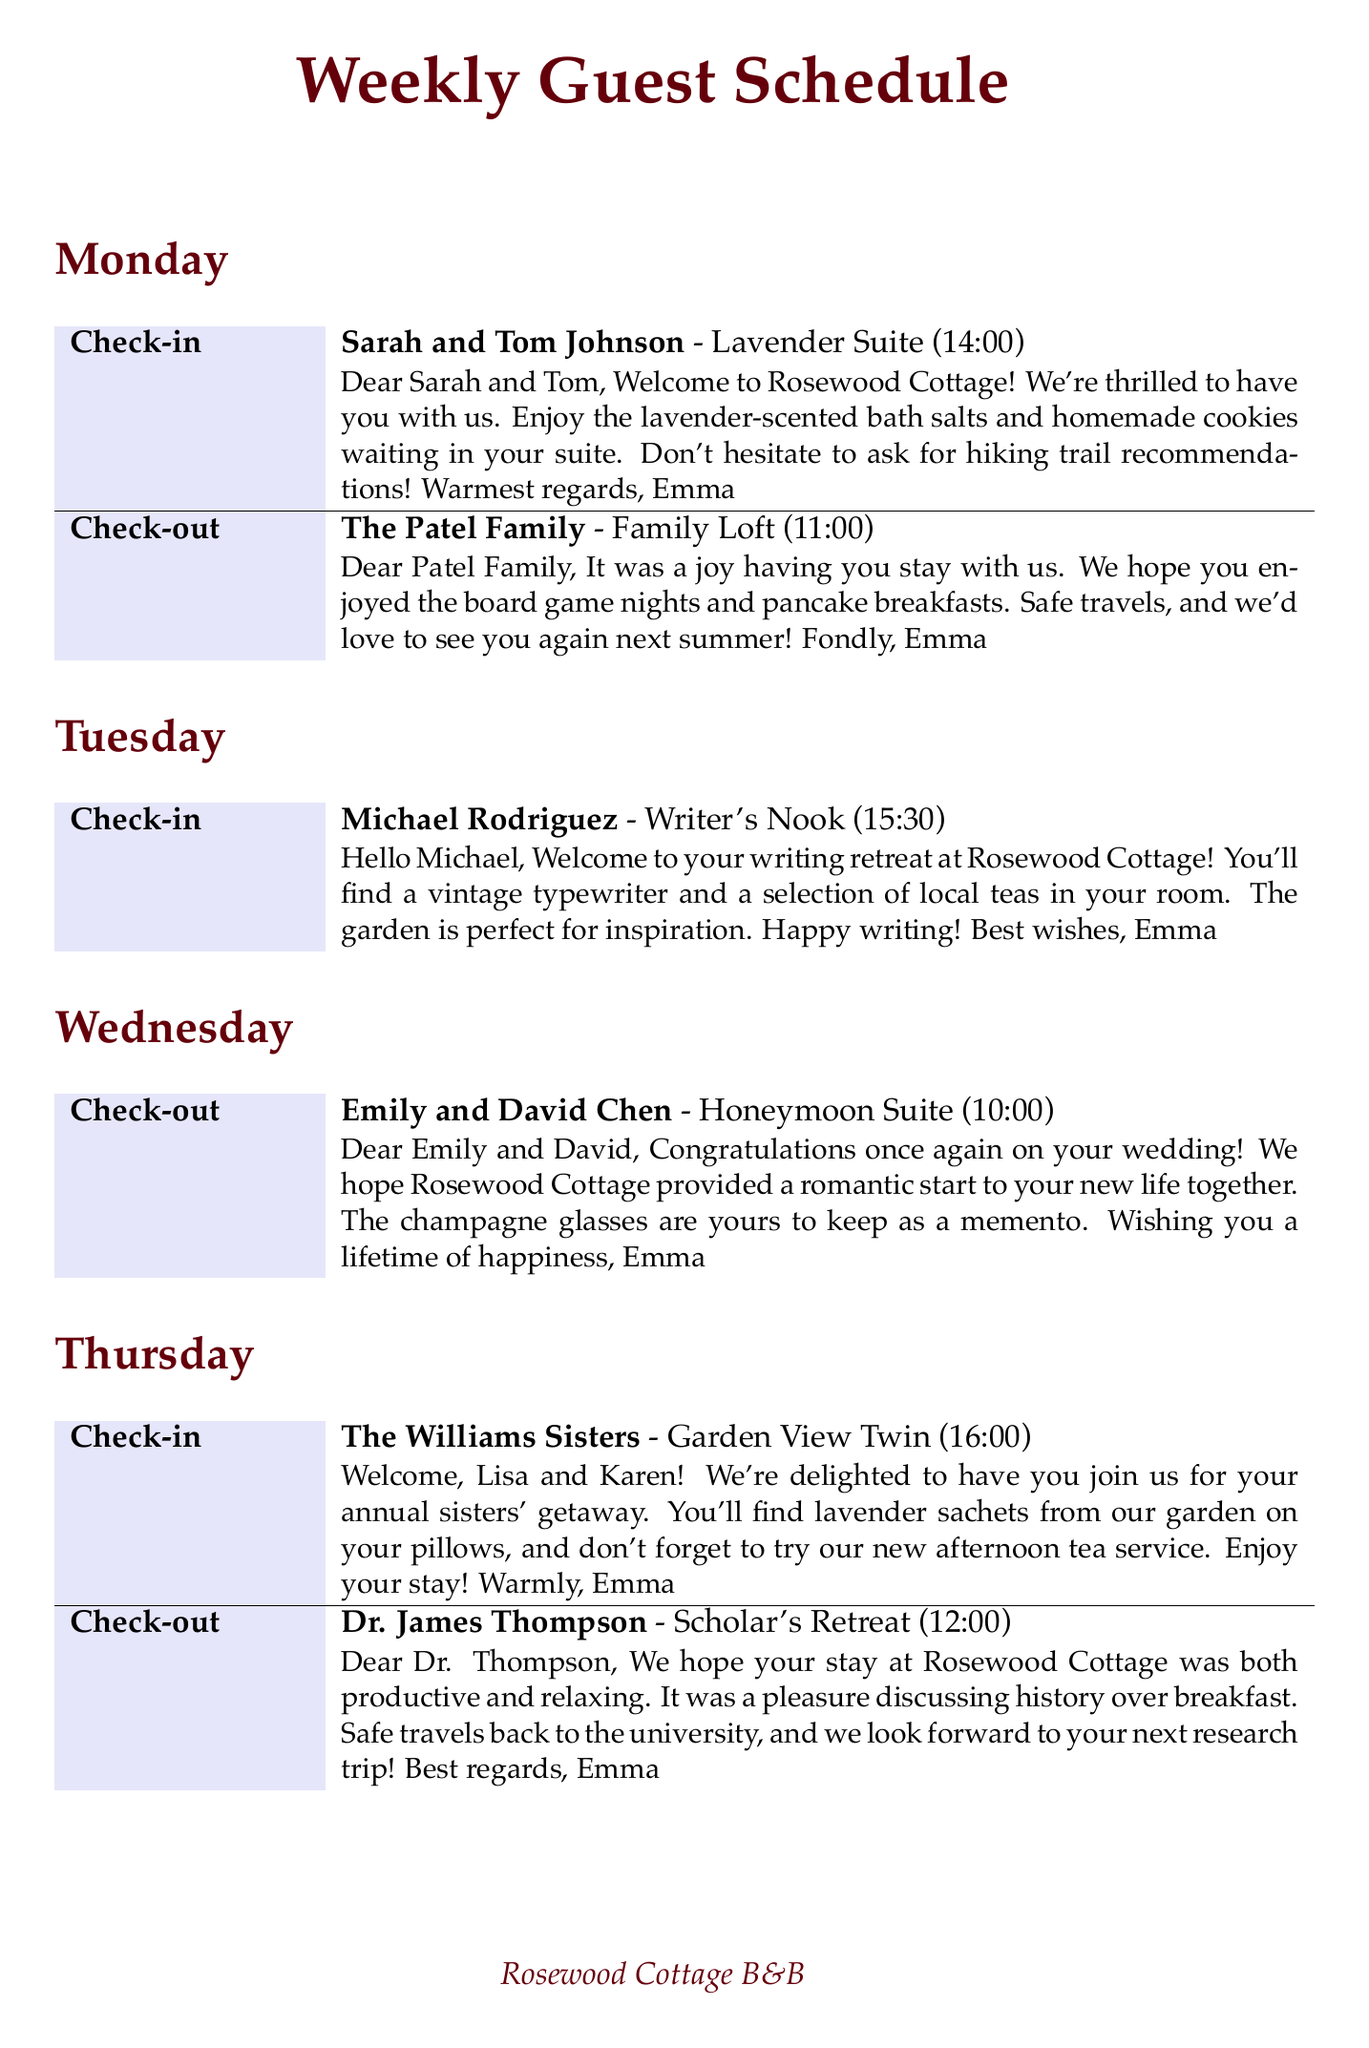What is the check-in time for Sarah and Tom Johnson? The check-in time is listed next to their name in the schedule.
Answer: 14:00 Who is checking out on Thursday? The only guest with a check-out listed for Thursday is Dr. James Thompson.
Answer: Dr. James Thompson What room did Michael Rodriguez stay in? The room is specified next to Michael Rodriguez's check-in information.
Answer: Writer's Nook How many guests are checking in on Friday? The number of check-ins on Friday can be found by counting the entries in that day's check-in section.
Answer: 2 What is the farewell message for the Patel Family? The farewell message is provided in the check-out section for the Patel Family.
Answer: Dear Patel Family, It was a joy having you stay with us. We hope you enjoyed the board game nights and pancake breakfasts. Safe travels, and we'd love to see you again next summer! Fondly, Emma Which suite does Maria Schmidt stay in? The suite is identified next to Maria Schmidt's check-in information.
Answer: Artist's Loft What special item is provided for the Williams Sisters? The special item is mentioned in the welcome note for the Williams Sisters.
Answer: lavender sachets What time are the guests checking out on Sunday? The check-out time is found directly next to the guest's name in the schedule.
Answer: 11:00 What is the message for the Novak Family's welcome? The welcome note for the Novak Family is part of their check-in details.
Answer: Welcome, Novak Family! We're excited to have you experience Rosewood Cottage. The kids will find a treasure hunt map in their room, and we've prepared a picnic basket for your hike tomorrow. Let the adventure begin! Cheers, Emma 